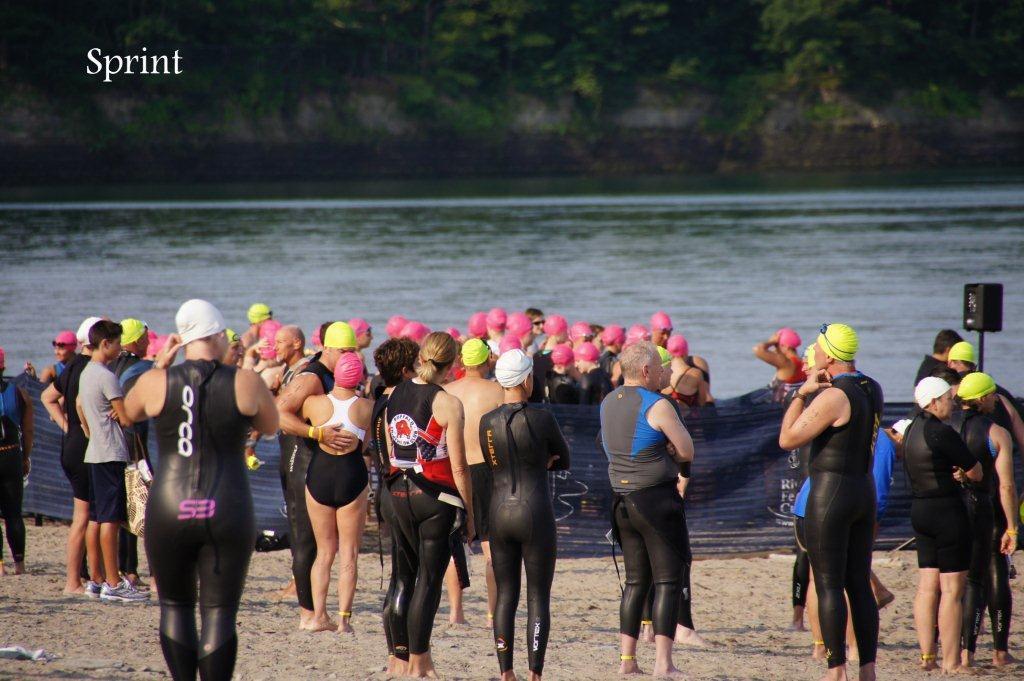How would you summarize this image in a sentence or two? In this picture there are people in the center of the image, they are wearing swimming costume and there is water in the center of the image, there are trees at the top side of the image. 